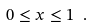Convert formula to latex. <formula><loc_0><loc_0><loc_500><loc_500>0 \leq x \leq 1 \ .</formula> 